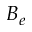Convert formula to latex. <formula><loc_0><loc_0><loc_500><loc_500>B _ { e }</formula> 